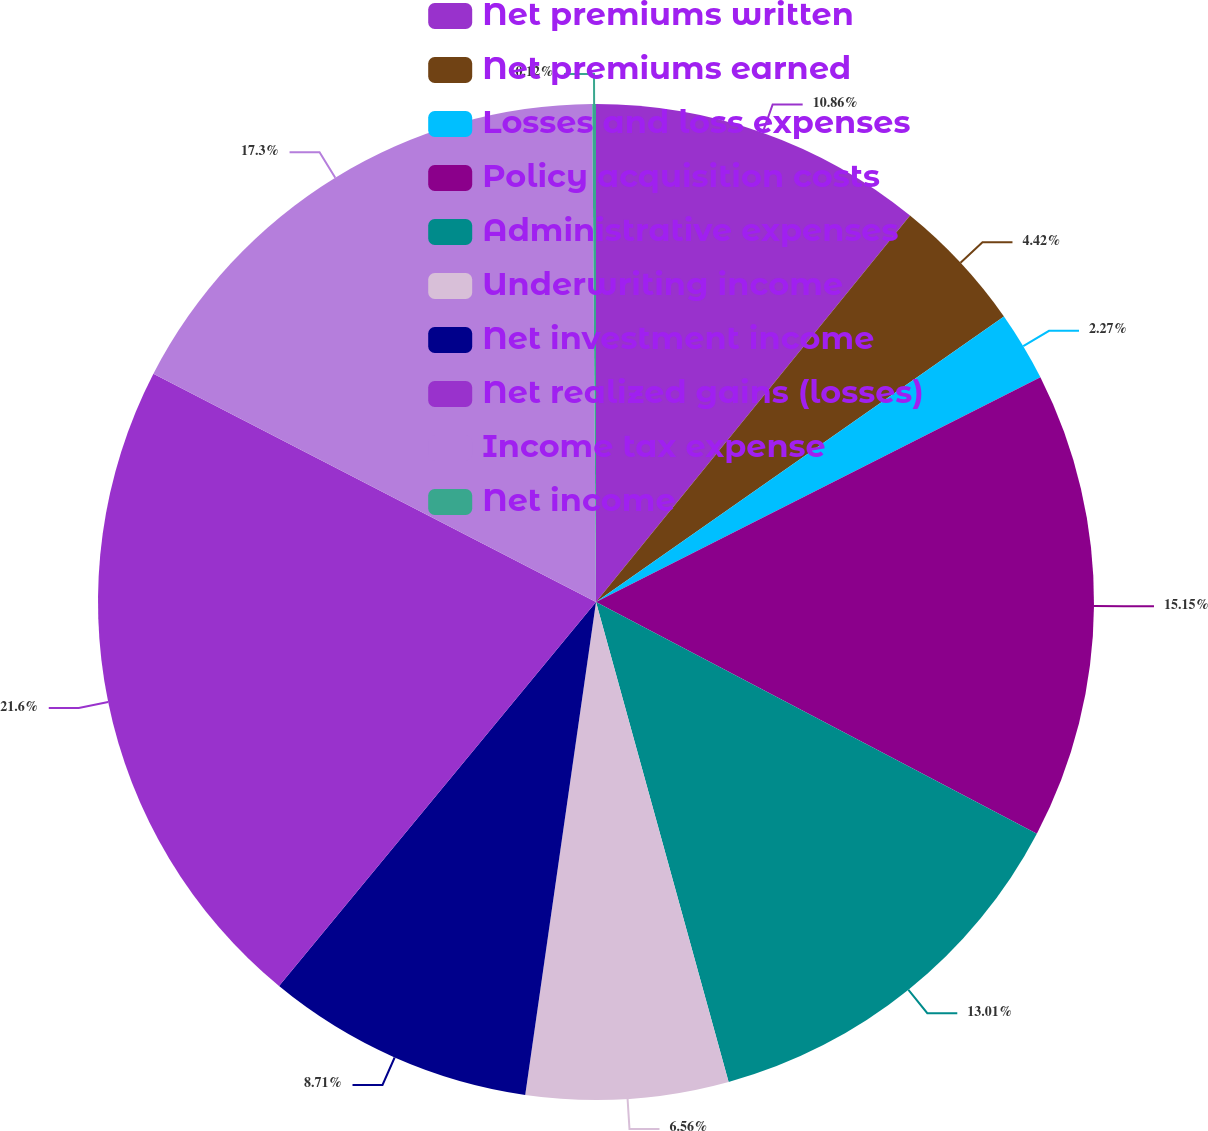Convert chart to OTSL. <chart><loc_0><loc_0><loc_500><loc_500><pie_chart><fcel>Net premiums written<fcel>Net premiums earned<fcel>Losses and loss expenses<fcel>Policy acquisition costs<fcel>Administrative expenses<fcel>Underwriting income<fcel>Net investment income<fcel>Net realized gains (losses)<fcel>Income tax expense<fcel>Net income<nl><fcel>10.86%<fcel>4.42%<fcel>2.27%<fcel>15.15%<fcel>13.01%<fcel>6.56%<fcel>8.71%<fcel>21.6%<fcel>17.3%<fcel>0.12%<nl></chart> 